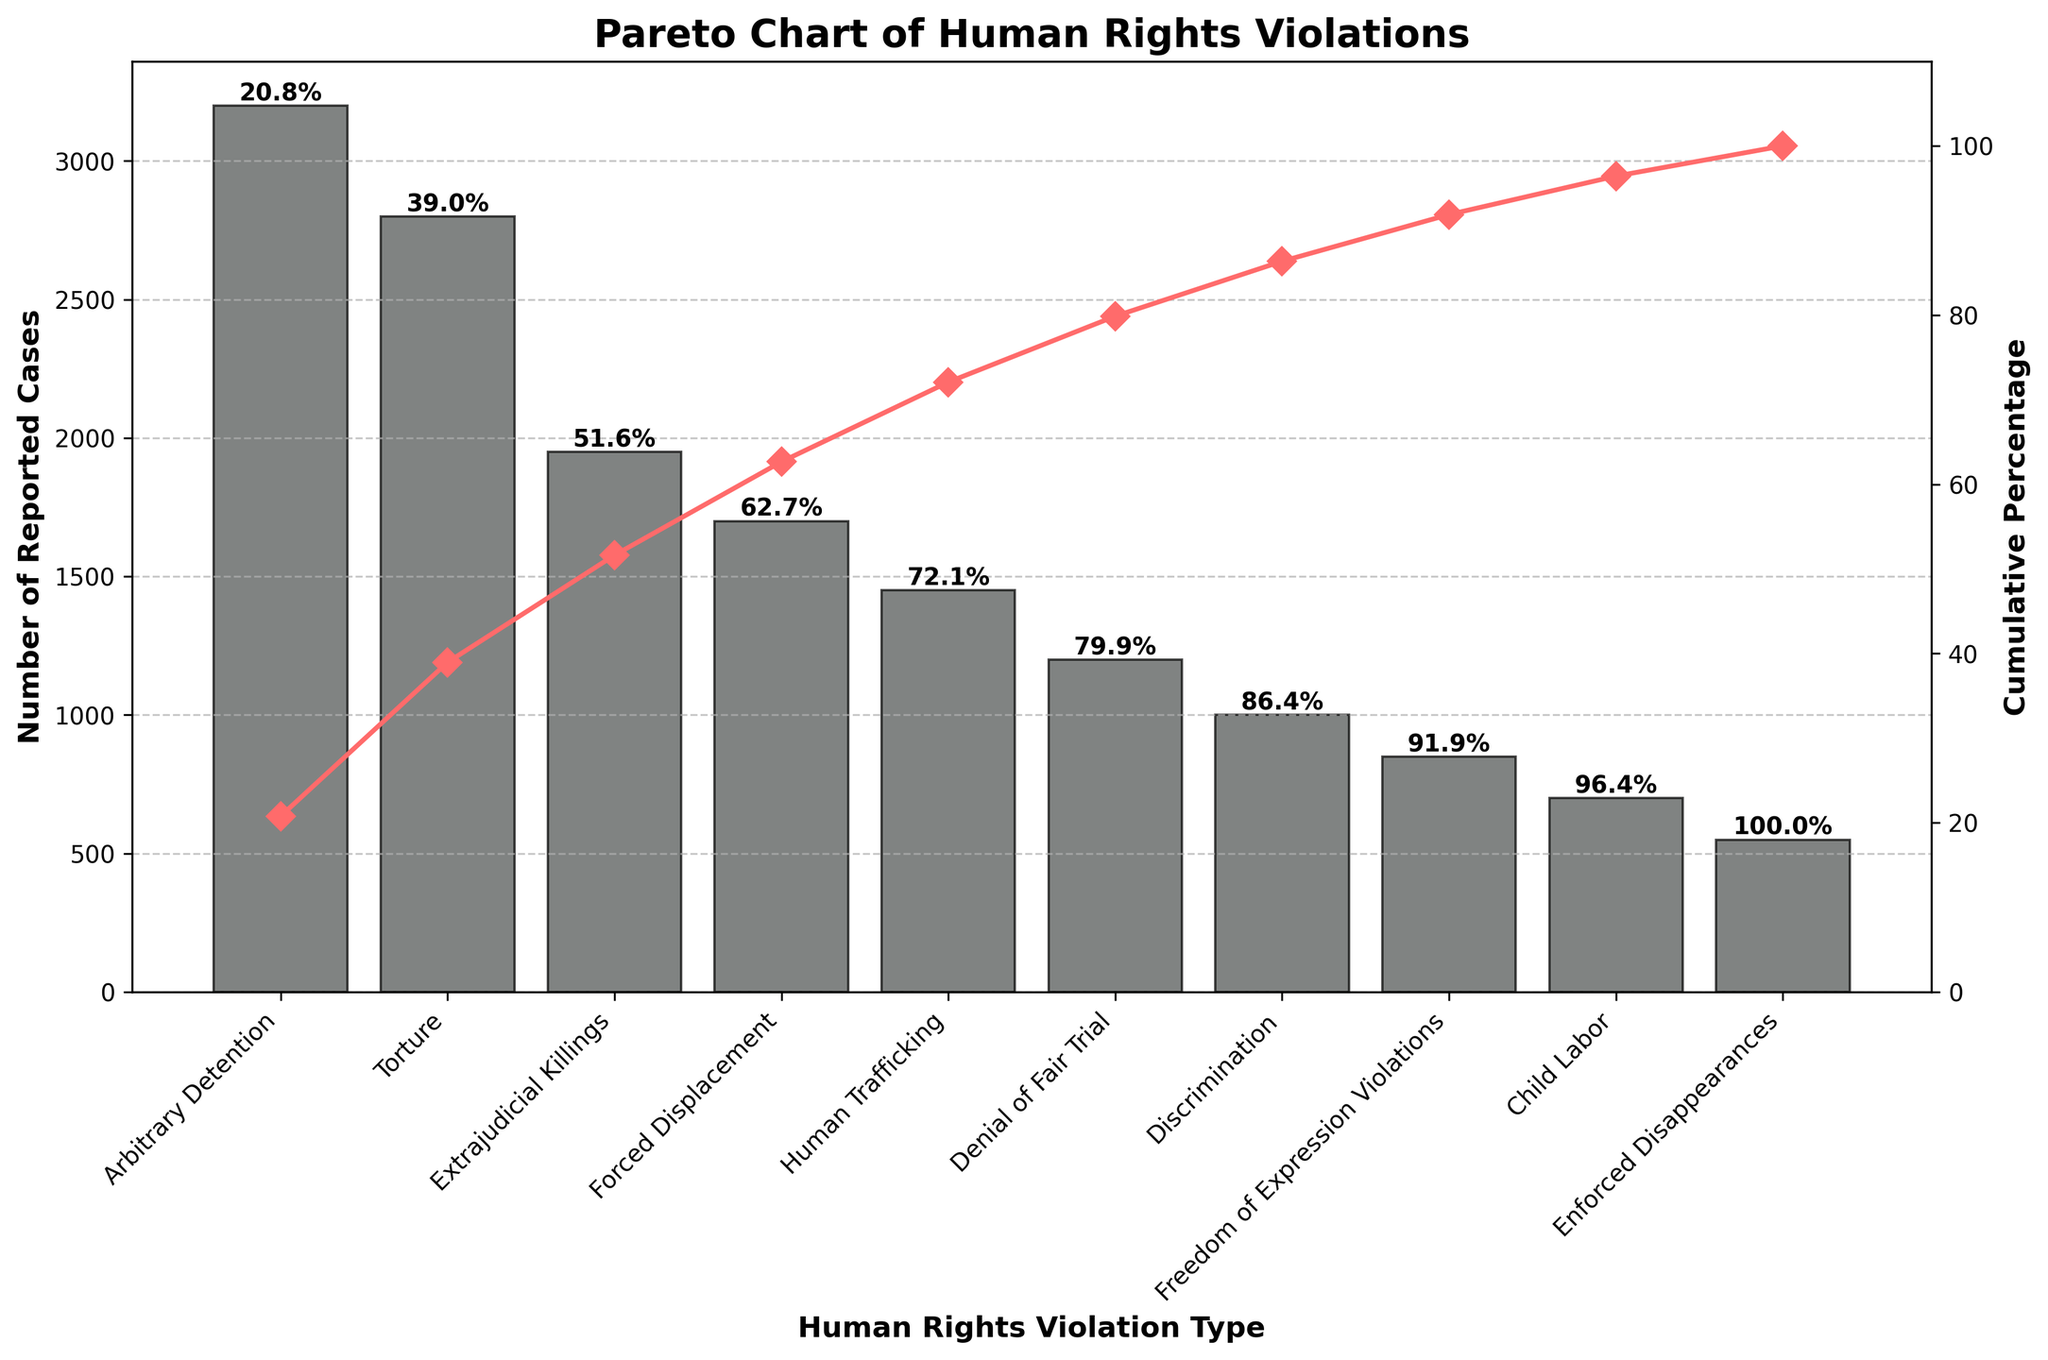What is the title of the chart? The title is typically placed at the top of the chart. In this case, the title clearly states the focus of the chart.
Answer: Pareto Chart of Human Rights Violations What are the top three types of human rights violations reported? The top three types can be identified by looking at the heights of the bars, which indicate the number of reported cases. The highest bars represent the top violations.
Answer: Arbitrary Detention, Torture, Extrajudicial Killings Which human rights violation has the fewest reported cases? The violation with the fewest reported cases will have the shortest bar on the chart.
Answer: Enforced Disappearances How many reported cases are there for Torture? The number of reported cases is given by the height of the bar corresponding to Torture.
Answer: 2800 What percentage of reported cases is represented by the top violation? To find this, locate the cumulative percentage label on top of the bar for Arbitrary Detention.
Answer: 17.1% What is the cumulative percentage after the third violation? The cumulative percentage after the third violation can be read from the label above the third bar, which corresponds to Extrajudicial Killings.
Answer: 54.3% How does the number of reported cases for Child Labor compare to Denial of Fair Trial? Compare the heights of the bars for Child Labor and Denial of Fair Trial to see which is taller or shorter.
Answer: Child Labor has fewer reported cases than Denial of Fair Trial What is the cumulative percentage for Freedom of Expression Violations? This can be found by looking at the cumulative percentage label above the Freedom of Expression Violations bar.
Answer: 91.8% What is the cumulative percentage for Human Trafficking? Read the cumulative percentage label at the top of the bar for Human Trafficking.
Answer: 78.6% 